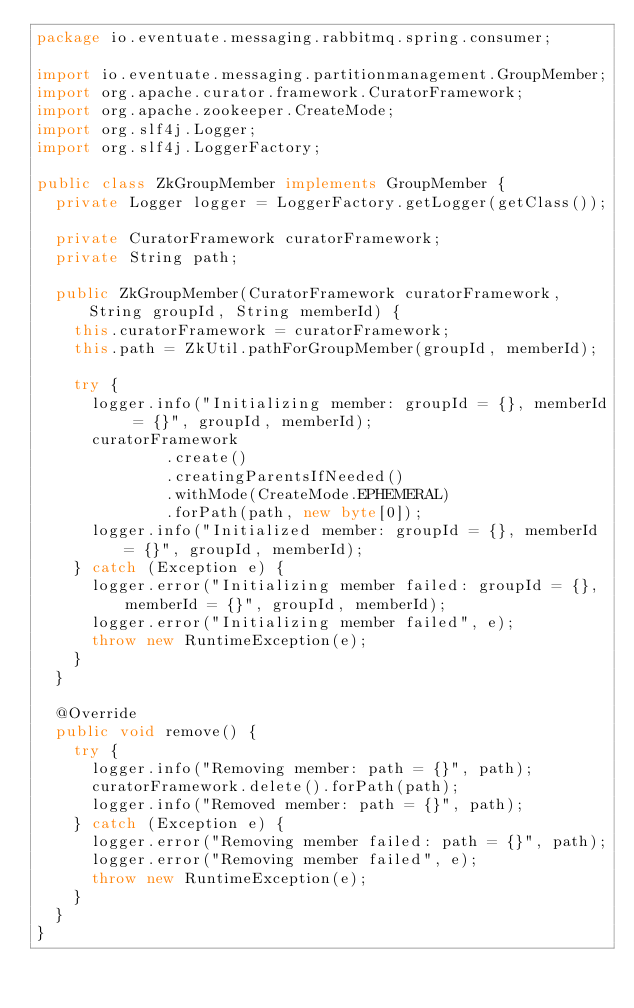<code> <loc_0><loc_0><loc_500><loc_500><_Java_>package io.eventuate.messaging.rabbitmq.spring.consumer;

import io.eventuate.messaging.partitionmanagement.GroupMember;
import org.apache.curator.framework.CuratorFramework;
import org.apache.zookeeper.CreateMode;
import org.slf4j.Logger;
import org.slf4j.LoggerFactory;

public class ZkGroupMember implements GroupMember {
  private Logger logger = LoggerFactory.getLogger(getClass());

  private CuratorFramework curatorFramework;
  private String path;

  public ZkGroupMember(CuratorFramework curatorFramework, String groupId, String memberId) {
    this.curatorFramework = curatorFramework;
    this.path = ZkUtil.pathForGroupMember(groupId, memberId);

    try {
      logger.info("Initializing member: groupId = {}, memberId = {}", groupId, memberId);
      curatorFramework
              .create()
              .creatingParentsIfNeeded()
              .withMode(CreateMode.EPHEMERAL)
              .forPath(path, new byte[0]);
      logger.info("Initialized member: groupId = {}, memberId = {}", groupId, memberId);
    } catch (Exception e) {
      logger.error("Initializing member failed: groupId = {}, memberId = {}", groupId, memberId);
      logger.error("Initializing member failed", e);
      throw new RuntimeException(e);
    }
  }

  @Override
  public void remove() {
    try {
      logger.info("Removing member: path = {}", path);
      curatorFramework.delete().forPath(path);
      logger.info("Removed member: path = {}", path);
    } catch (Exception e) {
      logger.error("Removing member failed: path = {}", path);
      logger.error("Removing member failed", e);
      throw new RuntimeException(e);
    }
  }
}
</code> 